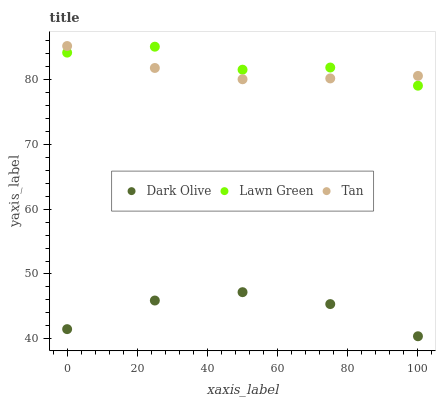Does Dark Olive have the minimum area under the curve?
Answer yes or no. Yes. Does Lawn Green have the maximum area under the curve?
Answer yes or no. Yes. Does Tan have the minimum area under the curve?
Answer yes or no. No. Does Tan have the maximum area under the curve?
Answer yes or no. No. Is Tan the smoothest?
Answer yes or no. Yes. Is Lawn Green the roughest?
Answer yes or no. Yes. Is Dark Olive the smoothest?
Answer yes or no. No. Is Dark Olive the roughest?
Answer yes or no. No. Does Dark Olive have the lowest value?
Answer yes or no. Yes. Does Tan have the lowest value?
Answer yes or no. No. Does Tan have the highest value?
Answer yes or no. Yes. Does Dark Olive have the highest value?
Answer yes or no. No. Is Dark Olive less than Tan?
Answer yes or no. Yes. Is Lawn Green greater than Dark Olive?
Answer yes or no. Yes. Does Tan intersect Lawn Green?
Answer yes or no. Yes. Is Tan less than Lawn Green?
Answer yes or no. No. Is Tan greater than Lawn Green?
Answer yes or no. No. Does Dark Olive intersect Tan?
Answer yes or no. No. 